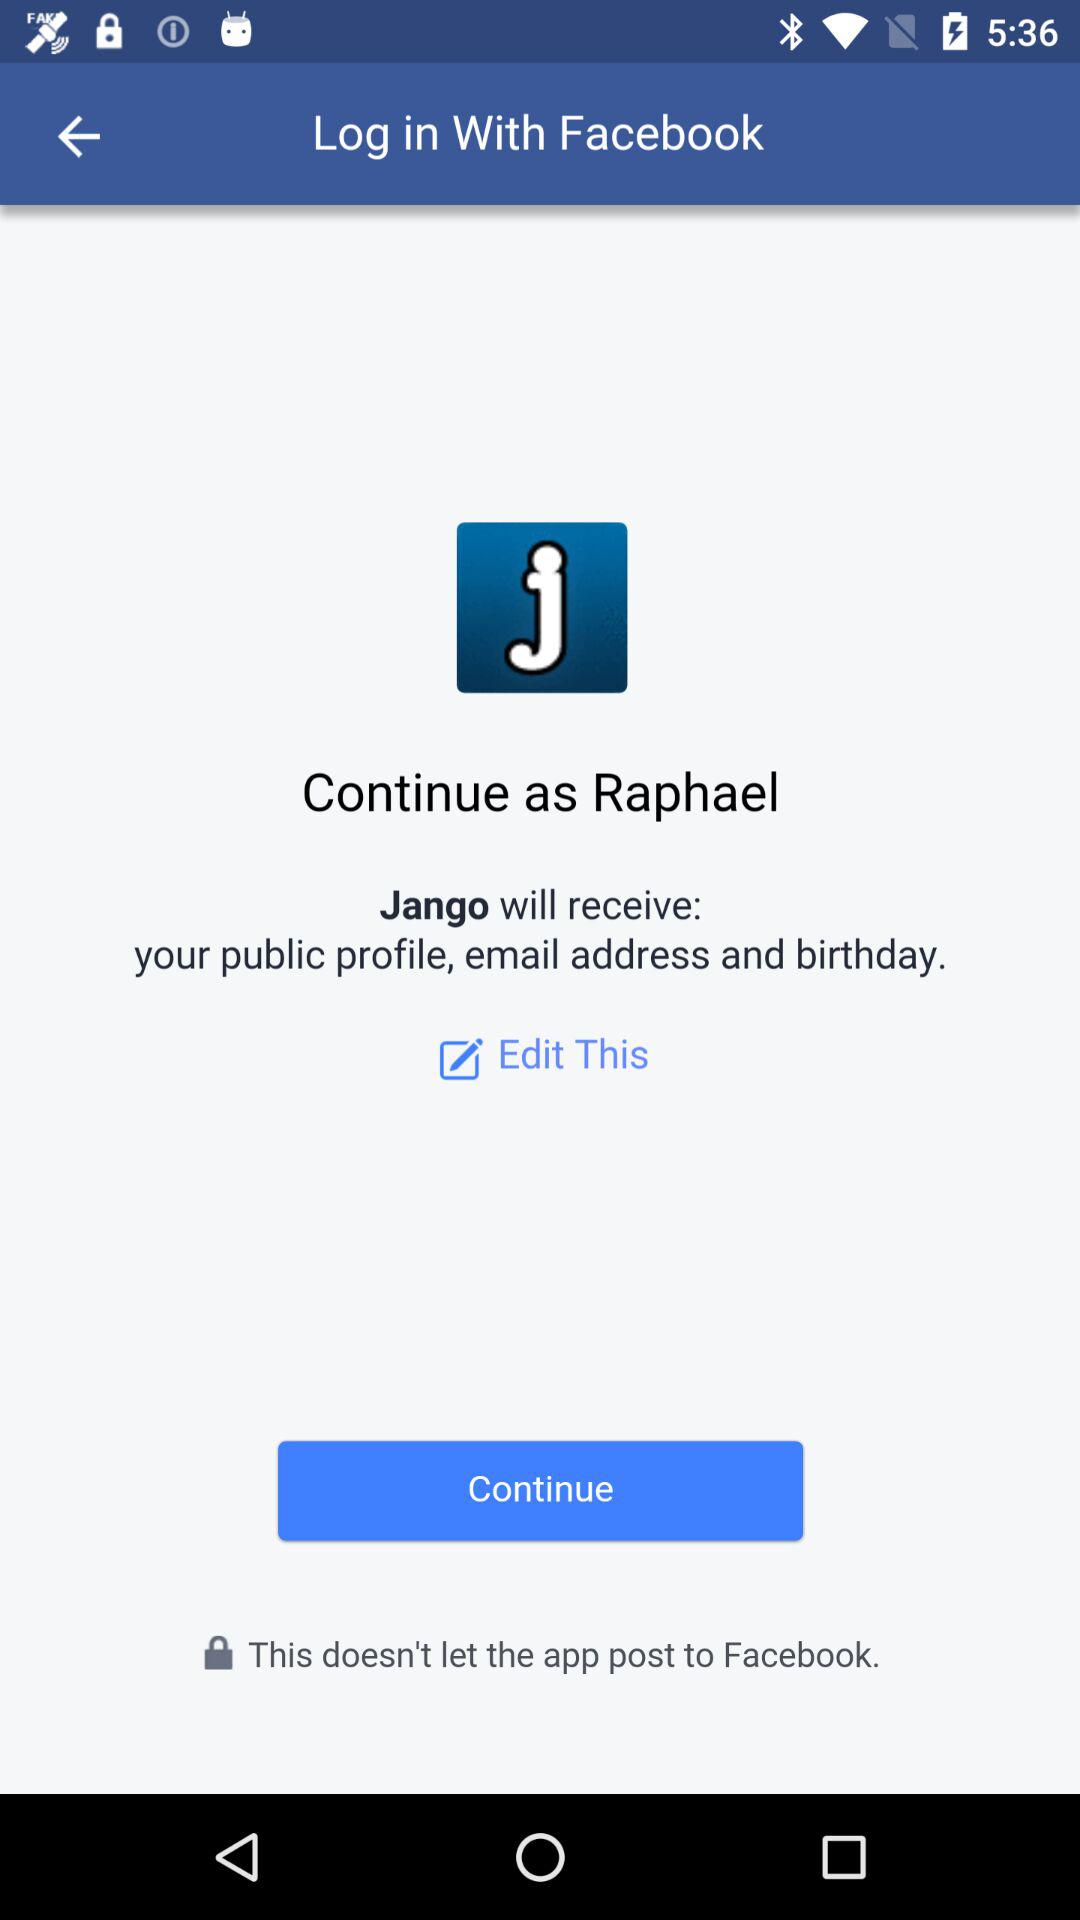Through what application can we log in? You can log in through "Facebook". 